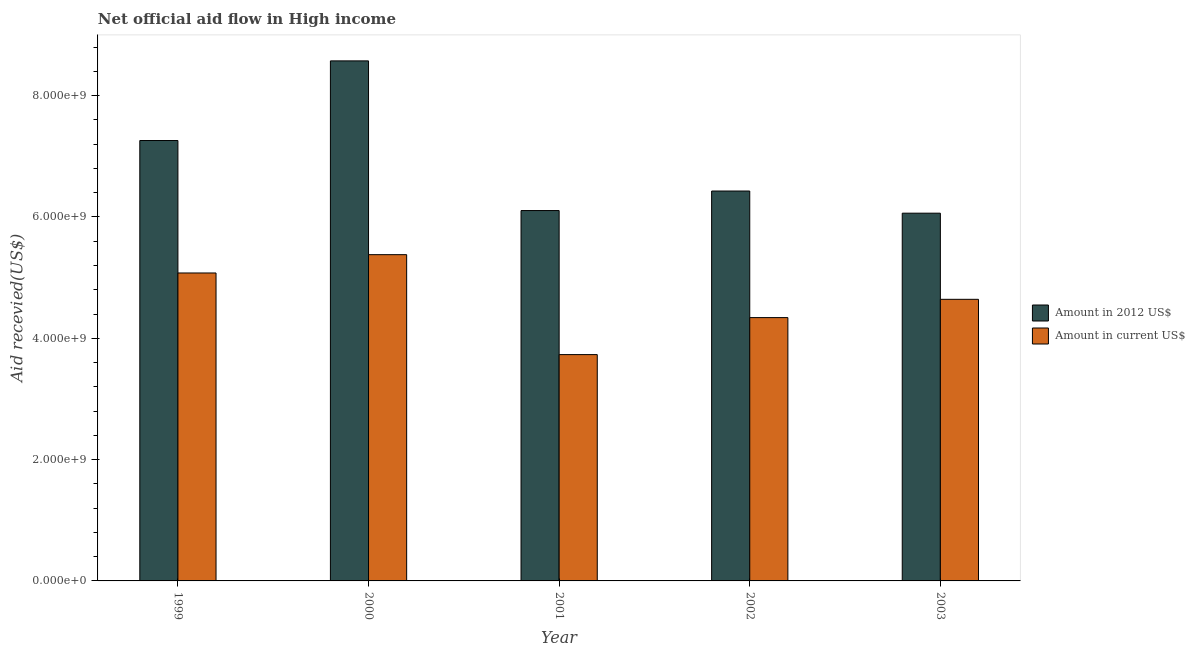How many different coloured bars are there?
Keep it short and to the point. 2. How many groups of bars are there?
Your answer should be very brief. 5. Are the number of bars on each tick of the X-axis equal?
Your answer should be compact. Yes. How many bars are there on the 4th tick from the left?
Your response must be concise. 2. What is the label of the 3rd group of bars from the left?
Your response must be concise. 2001. In how many cases, is the number of bars for a given year not equal to the number of legend labels?
Your answer should be very brief. 0. What is the amount of aid received(expressed in us$) in 2001?
Your answer should be compact. 3.73e+09. Across all years, what is the maximum amount of aid received(expressed in 2012 us$)?
Your response must be concise. 8.57e+09. Across all years, what is the minimum amount of aid received(expressed in 2012 us$)?
Make the answer very short. 6.06e+09. In which year was the amount of aid received(expressed in us$) minimum?
Provide a short and direct response. 2001. What is the total amount of aid received(expressed in 2012 us$) in the graph?
Provide a succinct answer. 3.44e+1. What is the difference between the amount of aid received(expressed in us$) in 2000 and that in 2003?
Keep it short and to the point. 7.36e+08. What is the difference between the amount of aid received(expressed in us$) in 1999 and the amount of aid received(expressed in 2012 us$) in 2002?
Your response must be concise. 7.36e+08. What is the average amount of aid received(expressed in 2012 us$) per year?
Make the answer very short. 6.89e+09. In the year 1999, what is the difference between the amount of aid received(expressed in 2012 us$) and amount of aid received(expressed in us$)?
Provide a succinct answer. 0. What is the ratio of the amount of aid received(expressed in 2012 us$) in 1999 to that in 2003?
Offer a terse response. 1.2. Is the amount of aid received(expressed in 2012 us$) in 1999 less than that in 2003?
Provide a succinct answer. No. Is the difference between the amount of aid received(expressed in 2012 us$) in 1999 and 2003 greater than the difference between the amount of aid received(expressed in us$) in 1999 and 2003?
Offer a terse response. No. What is the difference between the highest and the second highest amount of aid received(expressed in 2012 us$)?
Offer a very short reply. 1.31e+09. What is the difference between the highest and the lowest amount of aid received(expressed in us$)?
Your answer should be compact. 1.65e+09. In how many years, is the amount of aid received(expressed in 2012 us$) greater than the average amount of aid received(expressed in 2012 us$) taken over all years?
Offer a very short reply. 2. Is the sum of the amount of aid received(expressed in 2012 us$) in 2000 and 2003 greater than the maximum amount of aid received(expressed in us$) across all years?
Your answer should be compact. Yes. What does the 1st bar from the left in 2002 represents?
Your answer should be very brief. Amount in 2012 US$. What does the 2nd bar from the right in 2001 represents?
Make the answer very short. Amount in 2012 US$. Are all the bars in the graph horizontal?
Give a very brief answer. No. How many legend labels are there?
Provide a succinct answer. 2. How are the legend labels stacked?
Provide a succinct answer. Vertical. What is the title of the graph?
Give a very brief answer. Net official aid flow in High income. What is the label or title of the Y-axis?
Provide a succinct answer. Aid recevied(US$). What is the Aid recevied(US$) in Amount in 2012 US$ in 1999?
Your answer should be very brief. 7.26e+09. What is the Aid recevied(US$) of Amount in current US$ in 1999?
Provide a succinct answer. 5.08e+09. What is the Aid recevied(US$) of Amount in 2012 US$ in 2000?
Make the answer very short. 8.57e+09. What is the Aid recevied(US$) of Amount in current US$ in 2000?
Keep it short and to the point. 5.38e+09. What is the Aid recevied(US$) in Amount in 2012 US$ in 2001?
Keep it short and to the point. 6.11e+09. What is the Aid recevied(US$) in Amount in current US$ in 2001?
Your response must be concise. 3.73e+09. What is the Aid recevied(US$) of Amount in 2012 US$ in 2002?
Ensure brevity in your answer.  6.43e+09. What is the Aid recevied(US$) in Amount in current US$ in 2002?
Your answer should be very brief. 4.34e+09. What is the Aid recevied(US$) in Amount in 2012 US$ in 2003?
Give a very brief answer. 6.06e+09. What is the Aid recevied(US$) of Amount in current US$ in 2003?
Your response must be concise. 4.64e+09. Across all years, what is the maximum Aid recevied(US$) of Amount in 2012 US$?
Keep it short and to the point. 8.57e+09. Across all years, what is the maximum Aid recevied(US$) of Amount in current US$?
Your answer should be compact. 5.38e+09. Across all years, what is the minimum Aid recevied(US$) of Amount in 2012 US$?
Your answer should be compact. 6.06e+09. Across all years, what is the minimum Aid recevied(US$) of Amount in current US$?
Make the answer very short. 3.73e+09. What is the total Aid recevied(US$) in Amount in 2012 US$ in the graph?
Your answer should be compact. 3.44e+1. What is the total Aid recevied(US$) of Amount in current US$ in the graph?
Offer a terse response. 2.32e+1. What is the difference between the Aid recevied(US$) of Amount in 2012 US$ in 1999 and that in 2000?
Provide a short and direct response. -1.31e+09. What is the difference between the Aid recevied(US$) in Amount in current US$ in 1999 and that in 2000?
Keep it short and to the point. -3.02e+08. What is the difference between the Aid recevied(US$) of Amount in 2012 US$ in 1999 and that in 2001?
Keep it short and to the point. 1.15e+09. What is the difference between the Aid recevied(US$) of Amount in current US$ in 1999 and that in 2001?
Offer a very short reply. 1.35e+09. What is the difference between the Aid recevied(US$) in Amount in 2012 US$ in 1999 and that in 2002?
Your response must be concise. 8.33e+08. What is the difference between the Aid recevied(US$) in Amount in current US$ in 1999 and that in 2002?
Your response must be concise. 7.36e+08. What is the difference between the Aid recevied(US$) in Amount in 2012 US$ in 1999 and that in 2003?
Ensure brevity in your answer.  1.20e+09. What is the difference between the Aid recevied(US$) of Amount in current US$ in 1999 and that in 2003?
Provide a short and direct response. 4.34e+08. What is the difference between the Aid recevied(US$) in Amount in 2012 US$ in 2000 and that in 2001?
Your answer should be compact. 2.47e+09. What is the difference between the Aid recevied(US$) of Amount in current US$ in 2000 and that in 2001?
Provide a short and direct response. 1.65e+09. What is the difference between the Aid recevied(US$) of Amount in 2012 US$ in 2000 and that in 2002?
Offer a very short reply. 2.15e+09. What is the difference between the Aid recevied(US$) in Amount in current US$ in 2000 and that in 2002?
Ensure brevity in your answer.  1.04e+09. What is the difference between the Aid recevied(US$) in Amount in 2012 US$ in 2000 and that in 2003?
Make the answer very short. 2.51e+09. What is the difference between the Aid recevied(US$) of Amount in current US$ in 2000 and that in 2003?
Provide a short and direct response. 7.36e+08. What is the difference between the Aid recevied(US$) in Amount in 2012 US$ in 2001 and that in 2002?
Keep it short and to the point. -3.22e+08. What is the difference between the Aid recevied(US$) in Amount in current US$ in 2001 and that in 2002?
Your response must be concise. -6.10e+08. What is the difference between the Aid recevied(US$) of Amount in 2012 US$ in 2001 and that in 2003?
Ensure brevity in your answer.  4.32e+07. What is the difference between the Aid recevied(US$) of Amount in current US$ in 2001 and that in 2003?
Provide a short and direct response. -9.11e+08. What is the difference between the Aid recevied(US$) of Amount in 2012 US$ in 2002 and that in 2003?
Provide a short and direct response. 3.65e+08. What is the difference between the Aid recevied(US$) in Amount in current US$ in 2002 and that in 2003?
Provide a short and direct response. -3.01e+08. What is the difference between the Aid recevied(US$) in Amount in 2012 US$ in 1999 and the Aid recevied(US$) in Amount in current US$ in 2000?
Your answer should be very brief. 1.88e+09. What is the difference between the Aid recevied(US$) of Amount in 2012 US$ in 1999 and the Aid recevied(US$) of Amount in current US$ in 2001?
Your answer should be very brief. 3.53e+09. What is the difference between the Aid recevied(US$) of Amount in 2012 US$ in 1999 and the Aid recevied(US$) of Amount in current US$ in 2002?
Make the answer very short. 2.92e+09. What is the difference between the Aid recevied(US$) of Amount in 2012 US$ in 1999 and the Aid recevied(US$) of Amount in current US$ in 2003?
Keep it short and to the point. 2.62e+09. What is the difference between the Aid recevied(US$) of Amount in 2012 US$ in 2000 and the Aid recevied(US$) of Amount in current US$ in 2001?
Your response must be concise. 4.84e+09. What is the difference between the Aid recevied(US$) in Amount in 2012 US$ in 2000 and the Aid recevied(US$) in Amount in current US$ in 2002?
Give a very brief answer. 4.23e+09. What is the difference between the Aid recevied(US$) of Amount in 2012 US$ in 2000 and the Aid recevied(US$) of Amount in current US$ in 2003?
Keep it short and to the point. 3.93e+09. What is the difference between the Aid recevied(US$) of Amount in 2012 US$ in 2001 and the Aid recevied(US$) of Amount in current US$ in 2002?
Provide a succinct answer. 1.76e+09. What is the difference between the Aid recevied(US$) of Amount in 2012 US$ in 2001 and the Aid recevied(US$) of Amount in current US$ in 2003?
Keep it short and to the point. 1.46e+09. What is the difference between the Aid recevied(US$) in Amount in 2012 US$ in 2002 and the Aid recevied(US$) in Amount in current US$ in 2003?
Offer a terse response. 1.79e+09. What is the average Aid recevied(US$) in Amount in 2012 US$ per year?
Keep it short and to the point. 6.89e+09. What is the average Aid recevied(US$) of Amount in current US$ per year?
Keep it short and to the point. 4.63e+09. In the year 1999, what is the difference between the Aid recevied(US$) in Amount in 2012 US$ and Aid recevied(US$) in Amount in current US$?
Your answer should be compact. 2.18e+09. In the year 2000, what is the difference between the Aid recevied(US$) of Amount in 2012 US$ and Aid recevied(US$) of Amount in current US$?
Provide a succinct answer. 3.19e+09. In the year 2001, what is the difference between the Aid recevied(US$) in Amount in 2012 US$ and Aid recevied(US$) in Amount in current US$?
Ensure brevity in your answer.  2.37e+09. In the year 2002, what is the difference between the Aid recevied(US$) of Amount in 2012 US$ and Aid recevied(US$) of Amount in current US$?
Provide a succinct answer. 2.09e+09. In the year 2003, what is the difference between the Aid recevied(US$) in Amount in 2012 US$ and Aid recevied(US$) in Amount in current US$?
Your response must be concise. 1.42e+09. What is the ratio of the Aid recevied(US$) of Amount in 2012 US$ in 1999 to that in 2000?
Your answer should be compact. 0.85. What is the ratio of the Aid recevied(US$) in Amount in current US$ in 1999 to that in 2000?
Give a very brief answer. 0.94. What is the ratio of the Aid recevied(US$) of Amount in 2012 US$ in 1999 to that in 2001?
Offer a terse response. 1.19. What is the ratio of the Aid recevied(US$) in Amount in current US$ in 1999 to that in 2001?
Ensure brevity in your answer.  1.36. What is the ratio of the Aid recevied(US$) of Amount in 2012 US$ in 1999 to that in 2002?
Your answer should be compact. 1.13. What is the ratio of the Aid recevied(US$) in Amount in current US$ in 1999 to that in 2002?
Your response must be concise. 1.17. What is the ratio of the Aid recevied(US$) of Amount in 2012 US$ in 1999 to that in 2003?
Keep it short and to the point. 1.2. What is the ratio of the Aid recevied(US$) in Amount in current US$ in 1999 to that in 2003?
Provide a succinct answer. 1.09. What is the ratio of the Aid recevied(US$) in Amount in 2012 US$ in 2000 to that in 2001?
Provide a succinct answer. 1.4. What is the ratio of the Aid recevied(US$) in Amount in current US$ in 2000 to that in 2001?
Offer a very short reply. 1.44. What is the ratio of the Aid recevied(US$) in Amount in 2012 US$ in 2000 to that in 2002?
Give a very brief answer. 1.33. What is the ratio of the Aid recevied(US$) of Amount in current US$ in 2000 to that in 2002?
Offer a very short reply. 1.24. What is the ratio of the Aid recevied(US$) in Amount in 2012 US$ in 2000 to that in 2003?
Your response must be concise. 1.41. What is the ratio of the Aid recevied(US$) in Amount in current US$ in 2000 to that in 2003?
Give a very brief answer. 1.16. What is the ratio of the Aid recevied(US$) of Amount in 2012 US$ in 2001 to that in 2002?
Your answer should be very brief. 0.95. What is the ratio of the Aid recevied(US$) in Amount in current US$ in 2001 to that in 2002?
Your answer should be compact. 0.86. What is the ratio of the Aid recevied(US$) of Amount in 2012 US$ in 2001 to that in 2003?
Your answer should be compact. 1.01. What is the ratio of the Aid recevied(US$) in Amount in current US$ in 2001 to that in 2003?
Keep it short and to the point. 0.8. What is the ratio of the Aid recevied(US$) in Amount in 2012 US$ in 2002 to that in 2003?
Provide a succinct answer. 1.06. What is the ratio of the Aid recevied(US$) in Amount in current US$ in 2002 to that in 2003?
Your response must be concise. 0.94. What is the difference between the highest and the second highest Aid recevied(US$) of Amount in 2012 US$?
Your answer should be compact. 1.31e+09. What is the difference between the highest and the second highest Aid recevied(US$) of Amount in current US$?
Make the answer very short. 3.02e+08. What is the difference between the highest and the lowest Aid recevied(US$) in Amount in 2012 US$?
Ensure brevity in your answer.  2.51e+09. What is the difference between the highest and the lowest Aid recevied(US$) in Amount in current US$?
Give a very brief answer. 1.65e+09. 